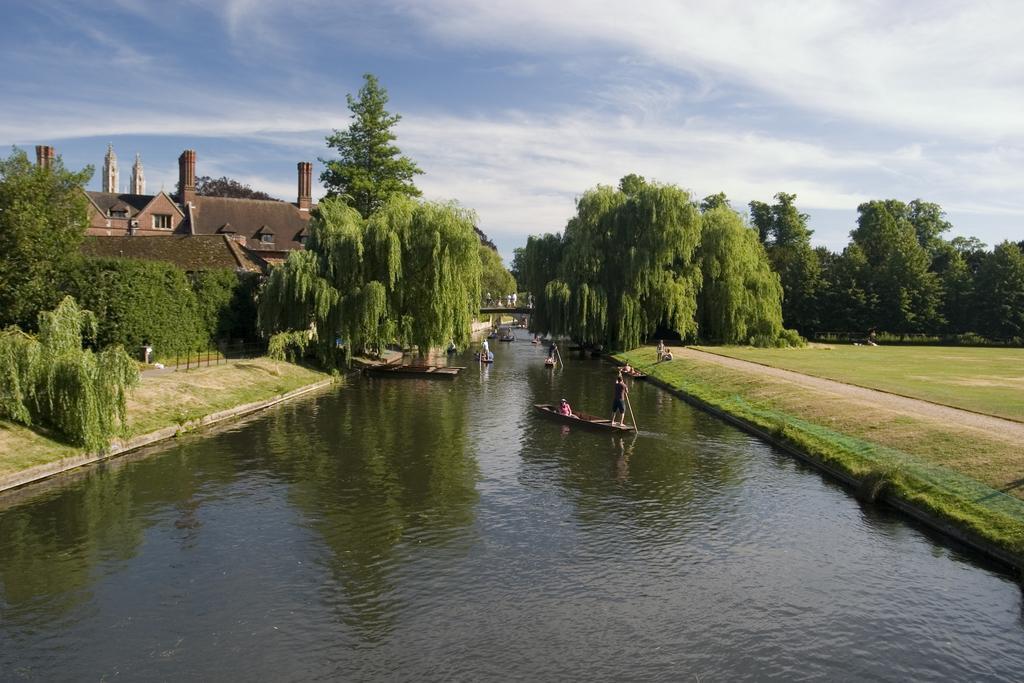In one or two sentences, can you explain what this image depicts? In this image there is a lake and there are people sailing in the boats. On both sides of the lake there are houses and trees. Image also consists of a fence, bridge to cross the lake and ground. At the top there is a sky with clouds. 